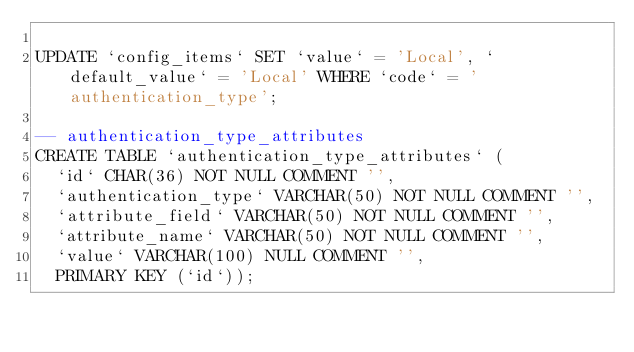<code> <loc_0><loc_0><loc_500><loc_500><_SQL_>
UPDATE `config_items` SET `value` = 'Local', `default_value` = 'Local' WHERE `code` = 'authentication_type';

-- authentication_type_attributes
CREATE TABLE `authentication_type_attributes` (
  `id` CHAR(36) NOT NULL COMMENT '',
  `authentication_type` VARCHAR(50) NOT NULL COMMENT '',
  `attribute_field` VARCHAR(50) NOT NULL COMMENT '',
  `attribute_name` VARCHAR(50) NOT NULL COMMENT '',
  `value` VARCHAR(100) NULL COMMENT '',
  PRIMARY KEY (`id`));
</code> 